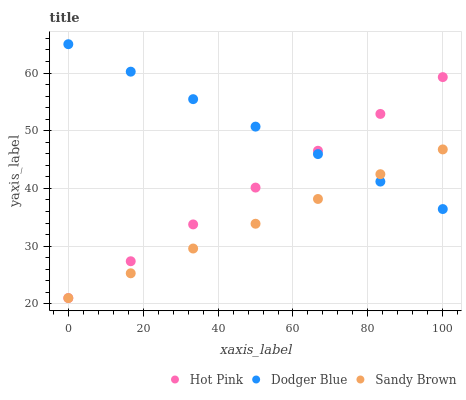Does Sandy Brown have the minimum area under the curve?
Answer yes or no. Yes. Does Dodger Blue have the maximum area under the curve?
Answer yes or no. Yes. Does Hot Pink have the minimum area under the curve?
Answer yes or no. No. Does Hot Pink have the maximum area under the curve?
Answer yes or no. No. Is Sandy Brown the smoothest?
Answer yes or no. Yes. Is Dodger Blue the roughest?
Answer yes or no. Yes. Is Hot Pink the smoothest?
Answer yes or no. No. Is Hot Pink the roughest?
Answer yes or no. No. Does Sandy Brown have the lowest value?
Answer yes or no. Yes. Does Dodger Blue have the lowest value?
Answer yes or no. No. Does Dodger Blue have the highest value?
Answer yes or no. Yes. Does Hot Pink have the highest value?
Answer yes or no. No. Does Sandy Brown intersect Hot Pink?
Answer yes or no. Yes. Is Sandy Brown less than Hot Pink?
Answer yes or no. No. Is Sandy Brown greater than Hot Pink?
Answer yes or no. No. 